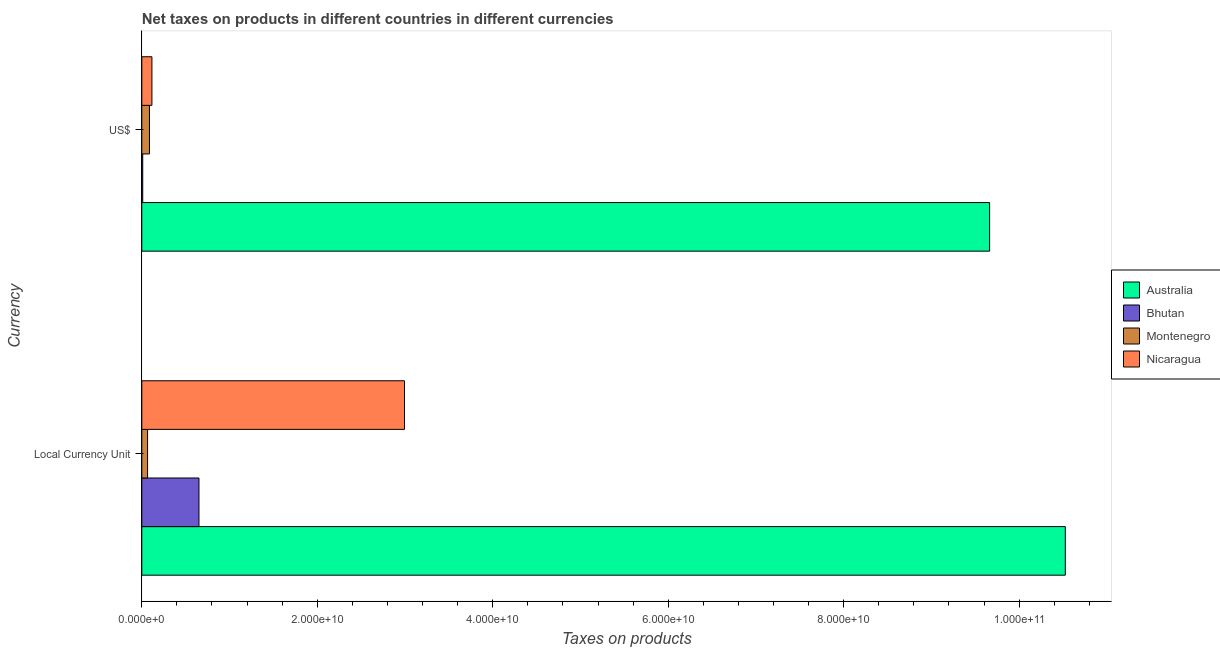How many different coloured bars are there?
Provide a short and direct response. 4. How many bars are there on the 1st tick from the bottom?
Make the answer very short. 4. What is the label of the 2nd group of bars from the top?
Give a very brief answer. Local Currency Unit. What is the net taxes in us$ in Montenegro?
Your answer should be very brief. 8.74e+08. Across all countries, what is the maximum net taxes in us$?
Give a very brief answer. 9.66e+1. Across all countries, what is the minimum net taxes in constant 2005 us$?
Offer a terse response. 6.58e+08. In which country was the net taxes in us$ maximum?
Offer a terse response. Australia. In which country was the net taxes in constant 2005 us$ minimum?
Keep it short and to the point. Montenegro. What is the total net taxes in us$ in the graph?
Offer a very short reply. 9.88e+1. What is the difference between the net taxes in us$ in Montenegro and that in Australia?
Give a very brief answer. -9.58e+1. What is the difference between the net taxes in constant 2005 us$ in Nicaragua and the net taxes in us$ in Australia?
Offer a terse response. -6.67e+1. What is the average net taxes in constant 2005 us$ per country?
Offer a very short reply. 3.56e+1. What is the difference between the net taxes in constant 2005 us$ and net taxes in us$ in Montenegro?
Provide a succinct answer. -2.15e+08. In how many countries, is the net taxes in constant 2005 us$ greater than 48000000000 units?
Your answer should be very brief. 1. What is the ratio of the net taxes in constant 2005 us$ in Bhutan to that in Nicaragua?
Ensure brevity in your answer.  0.22. Is the net taxes in constant 2005 us$ in Australia less than that in Montenegro?
Make the answer very short. No. What does the 1st bar from the top in Local Currency Unit represents?
Your answer should be very brief. Nicaragua. What does the 1st bar from the bottom in US$ represents?
Keep it short and to the point. Australia. How many bars are there?
Offer a very short reply. 8. How many countries are there in the graph?
Make the answer very short. 4. Are the values on the major ticks of X-axis written in scientific E-notation?
Keep it short and to the point. Yes. Does the graph contain grids?
Your answer should be compact. No. Where does the legend appear in the graph?
Ensure brevity in your answer.  Center right. How many legend labels are there?
Your answer should be compact. 4. What is the title of the graph?
Offer a very short reply. Net taxes on products in different countries in different currencies. What is the label or title of the X-axis?
Offer a terse response. Taxes on products. What is the label or title of the Y-axis?
Offer a terse response. Currency. What is the Taxes on products in Australia in Local Currency Unit?
Your answer should be very brief. 1.05e+11. What is the Taxes on products of Bhutan in Local Currency Unit?
Ensure brevity in your answer.  6.52e+09. What is the Taxes on products of Montenegro in Local Currency Unit?
Provide a succinct answer. 6.58e+08. What is the Taxes on products of Nicaragua in Local Currency Unit?
Provide a short and direct response. 2.99e+1. What is the Taxes on products of Australia in US$?
Keep it short and to the point. 9.66e+1. What is the Taxes on products in Bhutan in US$?
Give a very brief answer. 1.07e+08. What is the Taxes on products of Montenegro in US$?
Offer a terse response. 8.74e+08. What is the Taxes on products of Nicaragua in US$?
Provide a succinct answer. 1.15e+09. Across all Currency, what is the maximum Taxes on products of Australia?
Give a very brief answer. 1.05e+11. Across all Currency, what is the maximum Taxes on products of Bhutan?
Provide a short and direct response. 6.52e+09. Across all Currency, what is the maximum Taxes on products in Montenegro?
Provide a short and direct response. 8.74e+08. Across all Currency, what is the maximum Taxes on products in Nicaragua?
Make the answer very short. 2.99e+1. Across all Currency, what is the minimum Taxes on products in Australia?
Make the answer very short. 9.66e+1. Across all Currency, what is the minimum Taxes on products in Bhutan?
Offer a terse response. 1.07e+08. Across all Currency, what is the minimum Taxes on products of Montenegro?
Your answer should be very brief. 6.58e+08. Across all Currency, what is the minimum Taxes on products in Nicaragua?
Make the answer very short. 1.15e+09. What is the total Taxes on products in Australia in the graph?
Your answer should be very brief. 2.02e+11. What is the total Taxes on products in Bhutan in the graph?
Offer a terse response. 6.62e+09. What is the total Taxes on products in Montenegro in the graph?
Provide a succinct answer. 1.53e+09. What is the total Taxes on products of Nicaragua in the graph?
Provide a succinct answer. 3.11e+1. What is the difference between the Taxes on products in Australia in Local Currency Unit and that in US$?
Your answer should be compact. 8.63e+09. What is the difference between the Taxes on products of Bhutan in Local Currency Unit and that in US$?
Ensure brevity in your answer.  6.41e+09. What is the difference between the Taxes on products of Montenegro in Local Currency Unit and that in US$?
Provide a short and direct response. -2.15e+08. What is the difference between the Taxes on products of Nicaragua in Local Currency Unit and that in US$?
Provide a short and direct response. 2.88e+1. What is the difference between the Taxes on products in Australia in Local Currency Unit and the Taxes on products in Bhutan in US$?
Make the answer very short. 1.05e+11. What is the difference between the Taxes on products of Australia in Local Currency Unit and the Taxes on products of Montenegro in US$?
Keep it short and to the point. 1.04e+11. What is the difference between the Taxes on products in Australia in Local Currency Unit and the Taxes on products in Nicaragua in US$?
Offer a very short reply. 1.04e+11. What is the difference between the Taxes on products of Bhutan in Local Currency Unit and the Taxes on products of Montenegro in US$?
Ensure brevity in your answer.  5.64e+09. What is the difference between the Taxes on products of Bhutan in Local Currency Unit and the Taxes on products of Nicaragua in US$?
Provide a short and direct response. 5.36e+09. What is the difference between the Taxes on products in Montenegro in Local Currency Unit and the Taxes on products in Nicaragua in US$?
Keep it short and to the point. -4.95e+08. What is the average Taxes on products of Australia per Currency?
Make the answer very short. 1.01e+11. What is the average Taxes on products of Bhutan per Currency?
Offer a terse response. 3.31e+09. What is the average Taxes on products of Montenegro per Currency?
Ensure brevity in your answer.  7.66e+08. What is the average Taxes on products in Nicaragua per Currency?
Your response must be concise. 1.55e+1. What is the difference between the Taxes on products of Australia and Taxes on products of Bhutan in Local Currency Unit?
Make the answer very short. 9.88e+1. What is the difference between the Taxes on products of Australia and Taxes on products of Montenegro in Local Currency Unit?
Make the answer very short. 1.05e+11. What is the difference between the Taxes on products of Australia and Taxes on products of Nicaragua in Local Currency Unit?
Offer a terse response. 7.53e+1. What is the difference between the Taxes on products of Bhutan and Taxes on products of Montenegro in Local Currency Unit?
Provide a short and direct response. 5.86e+09. What is the difference between the Taxes on products of Bhutan and Taxes on products of Nicaragua in Local Currency Unit?
Your answer should be very brief. -2.34e+1. What is the difference between the Taxes on products in Montenegro and Taxes on products in Nicaragua in Local Currency Unit?
Keep it short and to the point. -2.93e+1. What is the difference between the Taxes on products in Australia and Taxes on products in Bhutan in US$?
Make the answer very short. 9.65e+1. What is the difference between the Taxes on products of Australia and Taxes on products of Montenegro in US$?
Provide a short and direct response. 9.58e+1. What is the difference between the Taxes on products in Australia and Taxes on products in Nicaragua in US$?
Offer a very short reply. 9.55e+1. What is the difference between the Taxes on products in Bhutan and Taxes on products in Montenegro in US$?
Your response must be concise. -7.67e+08. What is the difference between the Taxes on products in Bhutan and Taxes on products in Nicaragua in US$?
Provide a short and direct response. -1.05e+09. What is the difference between the Taxes on products of Montenegro and Taxes on products of Nicaragua in US$?
Provide a short and direct response. -2.80e+08. What is the ratio of the Taxes on products in Australia in Local Currency Unit to that in US$?
Offer a terse response. 1.09. What is the ratio of the Taxes on products of Bhutan in Local Currency Unit to that in US$?
Keep it short and to the point. 61.03. What is the ratio of the Taxes on products of Montenegro in Local Currency Unit to that in US$?
Provide a short and direct response. 0.75. What is the ratio of the Taxes on products in Nicaragua in Local Currency Unit to that in US$?
Your response must be concise. 25.96. What is the difference between the highest and the second highest Taxes on products of Australia?
Offer a very short reply. 8.63e+09. What is the difference between the highest and the second highest Taxes on products of Bhutan?
Give a very brief answer. 6.41e+09. What is the difference between the highest and the second highest Taxes on products in Montenegro?
Provide a succinct answer. 2.15e+08. What is the difference between the highest and the second highest Taxes on products in Nicaragua?
Keep it short and to the point. 2.88e+1. What is the difference between the highest and the lowest Taxes on products in Australia?
Provide a succinct answer. 8.63e+09. What is the difference between the highest and the lowest Taxes on products in Bhutan?
Make the answer very short. 6.41e+09. What is the difference between the highest and the lowest Taxes on products in Montenegro?
Give a very brief answer. 2.15e+08. What is the difference between the highest and the lowest Taxes on products of Nicaragua?
Make the answer very short. 2.88e+1. 